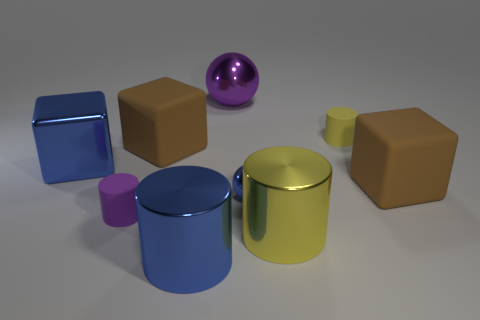Subtract all green spheres. How many brown blocks are left? 2 Subtract all yellow shiny cylinders. How many cylinders are left? 3 Subtract 1 cylinders. How many cylinders are left? 3 Subtract all blue cylinders. How many cylinders are left? 3 Add 1 large brown blocks. How many objects exist? 10 Subtract all cylinders. How many objects are left? 5 Subtract all gray blocks. Subtract all green spheres. How many blocks are left? 3 Add 6 brown matte balls. How many brown matte balls exist? 6 Subtract 1 blue cylinders. How many objects are left? 8 Subtract all tiny shiny things. Subtract all small blue shiny objects. How many objects are left? 7 